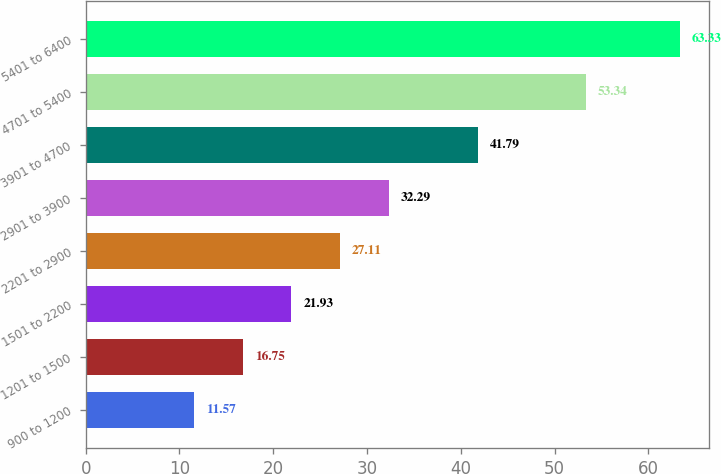Convert chart to OTSL. <chart><loc_0><loc_0><loc_500><loc_500><bar_chart><fcel>900 to 1200<fcel>1201 to 1500<fcel>1501 to 2200<fcel>2201 to 2900<fcel>2901 to 3900<fcel>3901 to 4700<fcel>4701 to 5400<fcel>5401 to 6400<nl><fcel>11.57<fcel>16.75<fcel>21.93<fcel>27.11<fcel>32.29<fcel>41.79<fcel>53.34<fcel>63.33<nl></chart> 